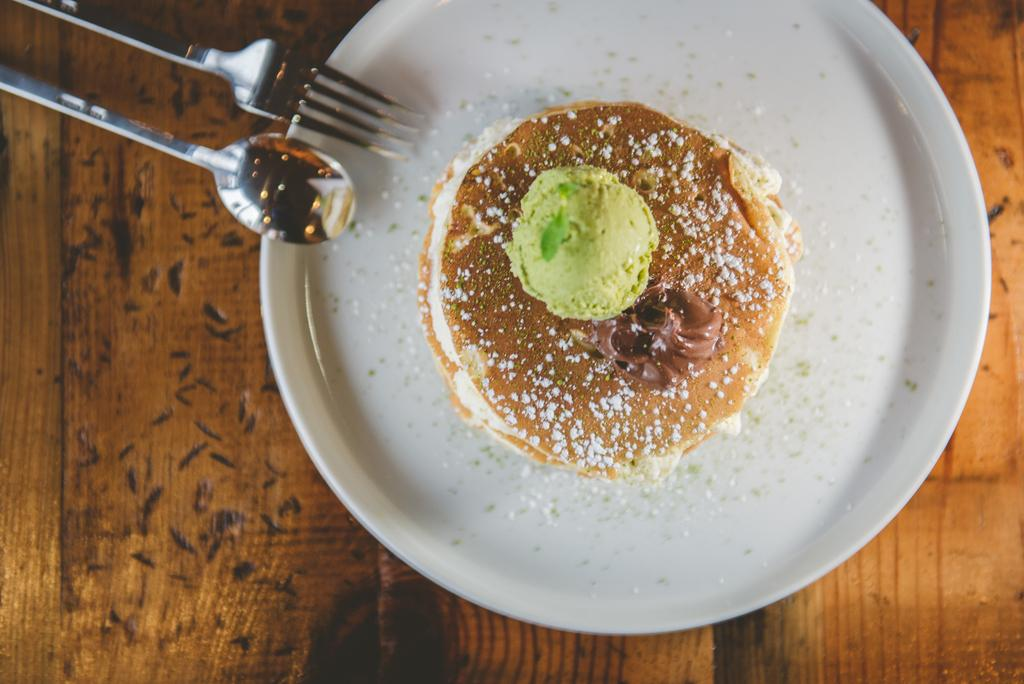What piece of furniture is present in the image? There is a table in the image. What is placed on the table? There is a plate on the table. What is on the plate? There is a bun on the plate. What utensils can be seen on the table? There are spoons on the table. What type of wool is being used to make the bun on the plate? There is no wool present in the image; the bun is likely made of dough or bread. 